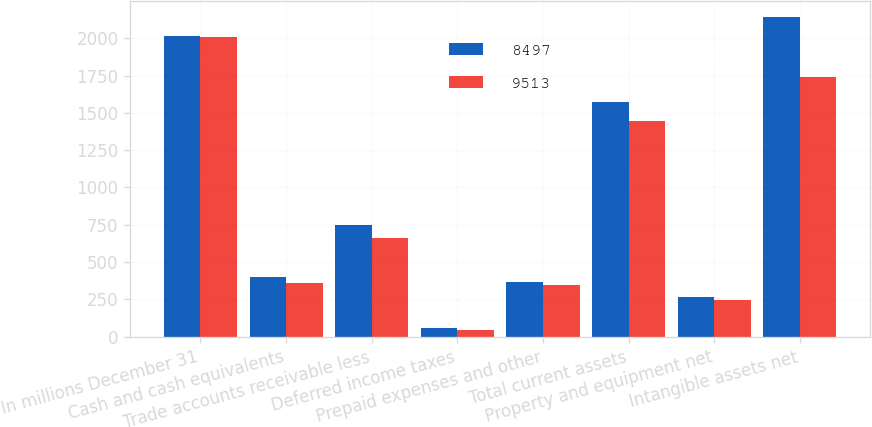Convert chart. <chart><loc_0><loc_0><loc_500><loc_500><stacked_bar_chart><ecel><fcel>In millions December 31<fcel>Cash and cash equivalents<fcel>Trade accounts receivable less<fcel>Deferred income taxes<fcel>Prepaid expenses and other<fcel>Total current assets<fcel>Property and equipment net<fcel>Intangible assets net<nl><fcel>8497<fcel>2013<fcel>400<fcel>751<fcel>55<fcel>366<fcel>1572<fcel>266<fcel>2142<nl><fcel>9513<fcel>2012<fcel>358<fcel>661<fcel>42<fcel>349<fcel>1443<fcel>248<fcel>1744<nl></chart> 